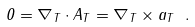<formula> <loc_0><loc_0><loc_500><loc_500>0 = \nabla _ { T } \cdot { A } _ { T } = \nabla _ { T } \times { a } _ { T } \ .</formula> 